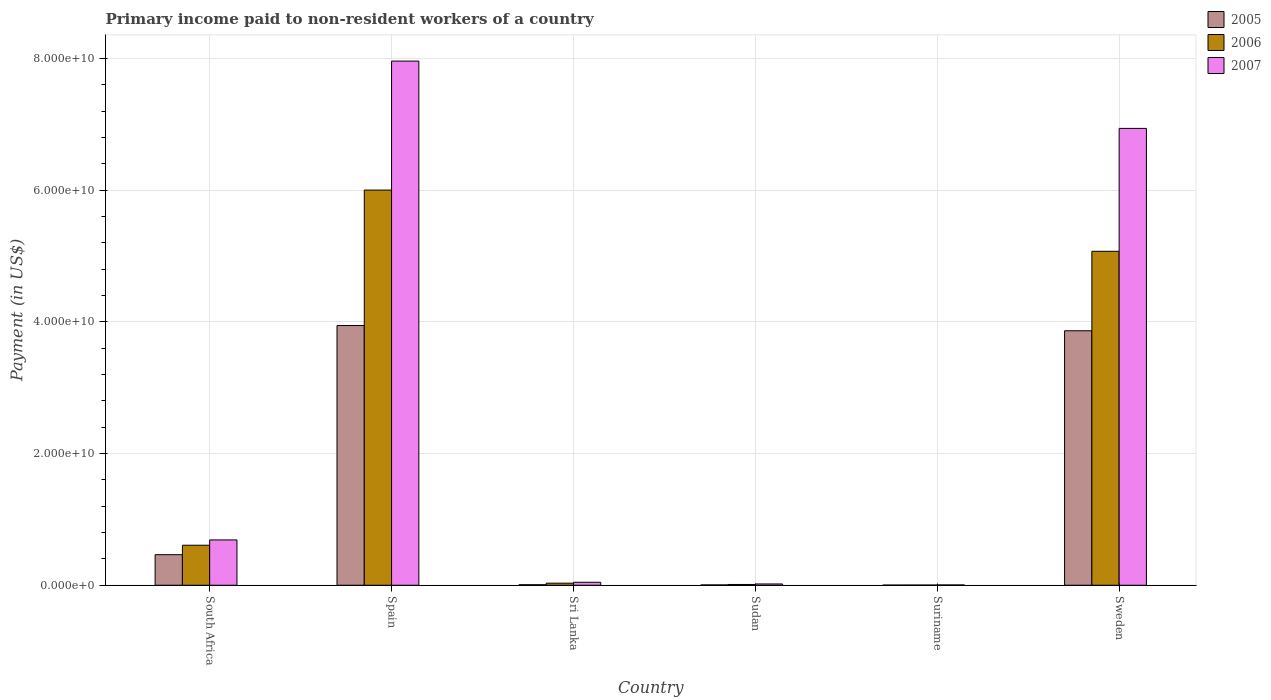How many bars are there on the 1st tick from the left?
Your answer should be very brief. 3. What is the amount paid to workers in 2007 in Suriname?
Offer a very short reply. 4.36e+07. Across all countries, what is the maximum amount paid to workers in 2005?
Provide a succinct answer. 3.94e+1. Across all countries, what is the minimum amount paid to workers in 2007?
Offer a terse response. 4.36e+07. In which country was the amount paid to workers in 2006 minimum?
Ensure brevity in your answer.  Suriname. What is the total amount paid to workers in 2007 in the graph?
Provide a succinct answer. 1.57e+11. What is the difference between the amount paid to workers in 2007 in South Africa and that in Spain?
Ensure brevity in your answer.  -7.27e+1. What is the difference between the amount paid to workers in 2006 in Sweden and the amount paid to workers in 2007 in Spain?
Give a very brief answer. -2.89e+1. What is the average amount paid to workers in 2006 per country?
Offer a terse response. 1.95e+1. What is the difference between the amount paid to workers of/in 2007 and amount paid to workers of/in 2005 in Suriname?
Keep it short and to the point. 1.96e+07. In how many countries, is the amount paid to workers in 2006 greater than 36000000000 US$?
Offer a very short reply. 2. What is the ratio of the amount paid to workers in 2005 in Spain to that in Sweden?
Provide a short and direct response. 1.02. What is the difference between the highest and the second highest amount paid to workers in 2006?
Keep it short and to the point. 9.30e+09. What is the difference between the highest and the lowest amount paid to workers in 2006?
Ensure brevity in your answer.  6.00e+1. In how many countries, is the amount paid to workers in 2005 greater than the average amount paid to workers in 2005 taken over all countries?
Provide a succinct answer. 2. Is the sum of the amount paid to workers in 2007 in Sri Lanka and Sudan greater than the maximum amount paid to workers in 2006 across all countries?
Your answer should be very brief. No. What does the 1st bar from the left in Sudan represents?
Keep it short and to the point. 2005. What does the 1st bar from the right in Suriname represents?
Give a very brief answer. 2007. Is it the case that in every country, the sum of the amount paid to workers in 2007 and amount paid to workers in 2005 is greater than the amount paid to workers in 2006?
Make the answer very short. Yes. How many bars are there?
Give a very brief answer. 18. Are all the bars in the graph horizontal?
Offer a terse response. No. How many countries are there in the graph?
Keep it short and to the point. 6. Are the values on the major ticks of Y-axis written in scientific E-notation?
Give a very brief answer. Yes. Does the graph contain grids?
Provide a short and direct response. Yes. Where does the legend appear in the graph?
Provide a short and direct response. Top right. How are the legend labels stacked?
Your response must be concise. Vertical. What is the title of the graph?
Keep it short and to the point. Primary income paid to non-resident workers of a country. What is the label or title of the Y-axis?
Your response must be concise. Payment (in US$). What is the Payment (in US$) of 2005 in South Africa?
Offer a very short reply. 4.64e+09. What is the Payment (in US$) of 2006 in South Africa?
Provide a succinct answer. 6.08e+09. What is the Payment (in US$) in 2007 in South Africa?
Your response must be concise. 6.88e+09. What is the Payment (in US$) in 2005 in Spain?
Ensure brevity in your answer.  3.94e+1. What is the Payment (in US$) of 2006 in Spain?
Your response must be concise. 6.00e+1. What is the Payment (in US$) in 2007 in Spain?
Your response must be concise. 7.96e+1. What is the Payment (in US$) in 2005 in Sri Lanka?
Your response must be concise. 7.59e+07. What is the Payment (in US$) in 2006 in Sri Lanka?
Provide a short and direct response. 3.12e+08. What is the Payment (in US$) of 2007 in Sri Lanka?
Give a very brief answer. 4.49e+08. What is the Payment (in US$) in 2005 in Sudan?
Provide a short and direct response. 4.79e+07. What is the Payment (in US$) in 2006 in Sudan?
Provide a succinct answer. 1.14e+08. What is the Payment (in US$) in 2007 in Sudan?
Offer a very short reply. 1.93e+08. What is the Payment (in US$) of 2005 in Suriname?
Give a very brief answer. 2.40e+07. What is the Payment (in US$) in 2006 in Suriname?
Keep it short and to the point. 2.50e+07. What is the Payment (in US$) of 2007 in Suriname?
Keep it short and to the point. 4.36e+07. What is the Payment (in US$) of 2005 in Sweden?
Give a very brief answer. 3.87e+1. What is the Payment (in US$) in 2006 in Sweden?
Keep it short and to the point. 5.07e+1. What is the Payment (in US$) in 2007 in Sweden?
Give a very brief answer. 6.94e+1. Across all countries, what is the maximum Payment (in US$) in 2005?
Provide a short and direct response. 3.94e+1. Across all countries, what is the maximum Payment (in US$) in 2006?
Your answer should be compact. 6.00e+1. Across all countries, what is the maximum Payment (in US$) of 2007?
Ensure brevity in your answer.  7.96e+1. Across all countries, what is the minimum Payment (in US$) of 2005?
Your response must be concise. 2.40e+07. Across all countries, what is the minimum Payment (in US$) of 2006?
Offer a very short reply. 2.50e+07. Across all countries, what is the minimum Payment (in US$) of 2007?
Provide a succinct answer. 4.36e+07. What is the total Payment (in US$) in 2005 in the graph?
Keep it short and to the point. 8.29e+1. What is the total Payment (in US$) of 2006 in the graph?
Give a very brief answer. 1.17e+11. What is the total Payment (in US$) in 2007 in the graph?
Give a very brief answer. 1.57e+11. What is the difference between the Payment (in US$) of 2005 in South Africa and that in Spain?
Offer a terse response. -3.48e+1. What is the difference between the Payment (in US$) in 2006 in South Africa and that in Spain?
Offer a terse response. -5.39e+1. What is the difference between the Payment (in US$) of 2007 in South Africa and that in Spain?
Provide a short and direct response. -7.27e+1. What is the difference between the Payment (in US$) of 2005 in South Africa and that in Sri Lanka?
Your response must be concise. 4.56e+09. What is the difference between the Payment (in US$) in 2006 in South Africa and that in Sri Lanka?
Provide a short and direct response. 5.77e+09. What is the difference between the Payment (in US$) of 2007 in South Africa and that in Sri Lanka?
Ensure brevity in your answer.  6.43e+09. What is the difference between the Payment (in US$) in 2005 in South Africa and that in Sudan?
Offer a very short reply. 4.59e+09. What is the difference between the Payment (in US$) of 2006 in South Africa and that in Sudan?
Offer a very short reply. 5.96e+09. What is the difference between the Payment (in US$) of 2007 in South Africa and that in Sudan?
Your answer should be compact. 6.69e+09. What is the difference between the Payment (in US$) in 2005 in South Africa and that in Suriname?
Your response must be concise. 4.62e+09. What is the difference between the Payment (in US$) of 2006 in South Africa and that in Suriname?
Keep it short and to the point. 6.05e+09. What is the difference between the Payment (in US$) of 2007 in South Africa and that in Suriname?
Your answer should be very brief. 6.84e+09. What is the difference between the Payment (in US$) in 2005 in South Africa and that in Sweden?
Provide a short and direct response. -3.40e+1. What is the difference between the Payment (in US$) in 2006 in South Africa and that in Sweden?
Ensure brevity in your answer.  -4.46e+1. What is the difference between the Payment (in US$) in 2007 in South Africa and that in Sweden?
Keep it short and to the point. -6.25e+1. What is the difference between the Payment (in US$) of 2005 in Spain and that in Sri Lanka?
Offer a very short reply. 3.94e+1. What is the difference between the Payment (in US$) in 2006 in Spain and that in Sri Lanka?
Make the answer very short. 5.97e+1. What is the difference between the Payment (in US$) in 2007 in Spain and that in Sri Lanka?
Provide a short and direct response. 7.92e+1. What is the difference between the Payment (in US$) of 2005 in Spain and that in Sudan?
Offer a terse response. 3.94e+1. What is the difference between the Payment (in US$) in 2006 in Spain and that in Sudan?
Give a very brief answer. 5.99e+1. What is the difference between the Payment (in US$) of 2007 in Spain and that in Sudan?
Offer a very short reply. 7.94e+1. What is the difference between the Payment (in US$) of 2005 in Spain and that in Suriname?
Offer a terse response. 3.94e+1. What is the difference between the Payment (in US$) of 2006 in Spain and that in Suriname?
Offer a terse response. 6.00e+1. What is the difference between the Payment (in US$) in 2007 in Spain and that in Suriname?
Provide a short and direct response. 7.96e+1. What is the difference between the Payment (in US$) of 2005 in Spain and that in Sweden?
Give a very brief answer. 7.95e+08. What is the difference between the Payment (in US$) in 2006 in Spain and that in Sweden?
Offer a very short reply. 9.30e+09. What is the difference between the Payment (in US$) of 2007 in Spain and that in Sweden?
Give a very brief answer. 1.02e+1. What is the difference between the Payment (in US$) in 2005 in Sri Lanka and that in Sudan?
Keep it short and to the point. 2.79e+07. What is the difference between the Payment (in US$) in 2006 in Sri Lanka and that in Sudan?
Make the answer very short. 1.97e+08. What is the difference between the Payment (in US$) of 2007 in Sri Lanka and that in Sudan?
Offer a very short reply. 2.56e+08. What is the difference between the Payment (in US$) in 2005 in Sri Lanka and that in Suriname?
Your answer should be compact. 5.19e+07. What is the difference between the Payment (in US$) in 2006 in Sri Lanka and that in Suriname?
Provide a succinct answer. 2.87e+08. What is the difference between the Payment (in US$) in 2007 in Sri Lanka and that in Suriname?
Keep it short and to the point. 4.06e+08. What is the difference between the Payment (in US$) of 2005 in Sri Lanka and that in Sweden?
Offer a very short reply. -3.86e+1. What is the difference between the Payment (in US$) of 2006 in Sri Lanka and that in Sweden?
Give a very brief answer. -5.04e+1. What is the difference between the Payment (in US$) in 2007 in Sri Lanka and that in Sweden?
Offer a terse response. -6.89e+1. What is the difference between the Payment (in US$) of 2005 in Sudan and that in Suriname?
Ensure brevity in your answer.  2.39e+07. What is the difference between the Payment (in US$) of 2006 in Sudan and that in Suriname?
Keep it short and to the point. 8.94e+07. What is the difference between the Payment (in US$) of 2007 in Sudan and that in Suriname?
Your answer should be compact. 1.49e+08. What is the difference between the Payment (in US$) in 2005 in Sudan and that in Sweden?
Provide a succinct answer. -3.86e+1. What is the difference between the Payment (in US$) of 2006 in Sudan and that in Sweden?
Provide a succinct answer. -5.06e+1. What is the difference between the Payment (in US$) of 2007 in Sudan and that in Sweden?
Provide a short and direct response. -6.92e+1. What is the difference between the Payment (in US$) of 2005 in Suriname and that in Sweden?
Your answer should be very brief. -3.86e+1. What is the difference between the Payment (in US$) of 2006 in Suriname and that in Sweden?
Provide a succinct answer. -5.07e+1. What is the difference between the Payment (in US$) in 2007 in Suriname and that in Sweden?
Keep it short and to the point. -6.93e+1. What is the difference between the Payment (in US$) of 2005 in South Africa and the Payment (in US$) of 2006 in Spain?
Provide a succinct answer. -5.54e+1. What is the difference between the Payment (in US$) of 2005 in South Africa and the Payment (in US$) of 2007 in Spain?
Your answer should be very brief. -7.50e+1. What is the difference between the Payment (in US$) in 2006 in South Africa and the Payment (in US$) in 2007 in Spain?
Your answer should be very brief. -7.35e+1. What is the difference between the Payment (in US$) in 2005 in South Africa and the Payment (in US$) in 2006 in Sri Lanka?
Provide a short and direct response. 4.33e+09. What is the difference between the Payment (in US$) of 2005 in South Africa and the Payment (in US$) of 2007 in Sri Lanka?
Keep it short and to the point. 4.19e+09. What is the difference between the Payment (in US$) of 2006 in South Africa and the Payment (in US$) of 2007 in Sri Lanka?
Offer a very short reply. 5.63e+09. What is the difference between the Payment (in US$) in 2005 in South Africa and the Payment (in US$) in 2006 in Sudan?
Offer a terse response. 4.53e+09. What is the difference between the Payment (in US$) of 2005 in South Africa and the Payment (in US$) of 2007 in Sudan?
Make the answer very short. 4.45e+09. What is the difference between the Payment (in US$) of 2006 in South Africa and the Payment (in US$) of 2007 in Sudan?
Make the answer very short. 5.89e+09. What is the difference between the Payment (in US$) in 2005 in South Africa and the Payment (in US$) in 2006 in Suriname?
Keep it short and to the point. 4.62e+09. What is the difference between the Payment (in US$) of 2005 in South Africa and the Payment (in US$) of 2007 in Suriname?
Your response must be concise. 4.60e+09. What is the difference between the Payment (in US$) in 2006 in South Africa and the Payment (in US$) in 2007 in Suriname?
Provide a succinct answer. 6.03e+09. What is the difference between the Payment (in US$) of 2005 in South Africa and the Payment (in US$) of 2006 in Sweden?
Give a very brief answer. -4.61e+1. What is the difference between the Payment (in US$) in 2005 in South Africa and the Payment (in US$) in 2007 in Sweden?
Keep it short and to the point. -6.47e+1. What is the difference between the Payment (in US$) of 2006 in South Africa and the Payment (in US$) of 2007 in Sweden?
Offer a very short reply. -6.33e+1. What is the difference between the Payment (in US$) in 2005 in Spain and the Payment (in US$) in 2006 in Sri Lanka?
Offer a very short reply. 3.91e+1. What is the difference between the Payment (in US$) of 2005 in Spain and the Payment (in US$) of 2007 in Sri Lanka?
Your response must be concise. 3.90e+1. What is the difference between the Payment (in US$) in 2006 in Spain and the Payment (in US$) in 2007 in Sri Lanka?
Offer a very short reply. 5.96e+1. What is the difference between the Payment (in US$) in 2005 in Spain and the Payment (in US$) in 2006 in Sudan?
Provide a succinct answer. 3.93e+1. What is the difference between the Payment (in US$) in 2005 in Spain and the Payment (in US$) in 2007 in Sudan?
Provide a short and direct response. 3.93e+1. What is the difference between the Payment (in US$) of 2006 in Spain and the Payment (in US$) of 2007 in Sudan?
Provide a succinct answer. 5.98e+1. What is the difference between the Payment (in US$) in 2005 in Spain and the Payment (in US$) in 2006 in Suriname?
Your response must be concise. 3.94e+1. What is the difference between the Payment (in US$) in 2005 in Spain and the Payment (in US$) in 2007 in Suriname?
Give a very brief answer. 3.94e+1. What is the difference between the Payment (in US$) of 2006 in Spain and the Payment (in US$) of 2007 in Suriname?
Make the answer very short. 6.00e+1. What is the difference between the Payment (in US$) in 2005 in Spain and the Payment (in US$) in 2006 in Sweden?
Your answer should be compact. -1.13e+1. What is the difference between the Payment (in US$) in 2005 in Spain and the Payment (in US$) in 2007 in Sweden?
Offer a very short reply. -2.99e+1. What is the difference between the Payment (in US$) in 2006 in Spain and the Payment (in US$) in 2007 in Sweden?
Provide a succinct answer. -9.37e+09. What is the difference between the Payment (in US$) of 2005 in Sri Lanka and the Payment (in US$) of 2006 in Sudan?
Your answer should be compact. -3.85e+07. What is the difference between the Payment (in US$) in 2005 in Sri Lanka and the Payment (in US$) in 2007 in Sudan?
Your answer should be compact. -1.17e+08. What is the difference between the Payment (in US$) in 2006 in Sri Lanka and the Payment (in US$) in 2007 in Sudan?
Keep it short and to the point. 1.19e+08. What is the difference between the Payment (in US$) of 2005 in Sri Lanka and the Payment (in US$) of 2006 in Suriname?
Provide a succinct answer. 5.09e+07. What is the difference between the Payment (in US$) in 2005 in Sri Lanka and the Payment (in US$) in 2007 in Suriname?
Keep it short and to the point. 3.23e+07. What is the difference between the Payment (in US$) in 2006 in Sri Lanka and the Payment (in US$) in 2007 in Suriname?
Provide a succinct answer. 2.68e+08. What is the difference between the Payment (in US$) of 2005 in Sri Lanka and the Payment (in US$) of 2006 in Sweden?
Ensure brevity in your answer.  -5.06e+1. What is the difference between the Payment (in US$) in 2005 in Sri Lanka and the Payment (in US$) in 2007 in Sweden?
Give a very brief answer. -6.93e+1. What is the difference between the Payment (in US$) in 2006 in Sri Lanka and the Payment (in US$) in 2007 in Sweden?
Your answer should be very brief. -6.91e+1. What is the difference between the Payment (in US$) in 2005 in Sudan and the Payment (in US$) in 2006 in Suriname?
Your answer should be compact. 2.29e+07. What is the difference between the Payment (in US$) in 2005 in Sudan and the Payment (in US$) in 2007 in Suriname?
Offer a terse response. 4.33e+06. What is the difference between the Payment (in US$) in 2006 in Sudan and the Payment (in US$) in 2007 in Suriname?
Keep it short and to the point. 7.08e+07. What is the difference between the Payment (in US$) in 2005 in Sudan and the Payment (in US$) in 2006 in Sweden?
Your response must be concise. -5.07e+1. What is the difference between the Payment (in US$) of 2005 in Sudan and the Payment (in US$) of 2007 in Sweden?
Provide a short and direct response. -6.93e+1. What is the difference between the Payment (in US$) of 2006 in Sudan and the Payment (in US$) of 2007 in Sweden?
Your answer should be compact. -6.93e+1. What is the difference between the Payment (in US$) of 2005 in Suriname and the Payment (in US$) of 2006 in Sweden?
Offer a very short reply. -5.07e+1. What is the difference between the Payment (in US$) of 2005 in Suriname and the Payment (in US$) of 2007 in Sweden?
Offer a terse response. -6.94e+1. What is the difference between the Payment (in US$) of 2006 in Suriname and the Payment (in US$) of 2007 in Sweden?
Ensure brevity in your answer.  -6.94e+1. What is the average Payment (in US$) of 2005 per country?
Your response must be concise. 1.38e+1. What is the average Payment (in US$) of 2006 per country?
Make the answer very short. 1.95e+1. What is the average Payment (in US$) in 2007 per country?
Offer a terse response. 2.61e+1. What is the difference between the Payment (in US$) in 2005 and Payment (in US$) in 2006 in South Africa?
Provide a short and direct response. -1.44e+09. What is the difference between the Payment (in US$) in 2005 and Payment (in US$) in 2007 in South Africa?
Keep it short and to the point. -2.24e+09. What is the difference between the Payment (in US$) in 2006 and Payment (in US$) in 2007 in South Africa?
Offer a very short reply. -8.03e+08. What is the difference between the Payment (in US$) of 2005 and Payment (in US$) of 2006 in Spain?
Ensure brevity in your answer.  -2.06e+1. What is the difference between the Payment (in US$) in 2005 and Payment (in US$) in 2007 in Spain?
Offer a very short reply. -4.02e+1. What is the difference between the Payment (in US$) of 2006 and Payment (in US$) of 2007 in Spain?
Your response must be concise. -1.96e+1. What is the difference between the Payment (in US$) in 2005 and Payment (in US$) in 2006 in Sri Lanka?
Your response must be concise. -2.36e+08. What is the difference between the Payment (in US$) in 2005 and Payment (in US$) in 2007 in Sri Lanka?
Keep it short and to the point. -3.73e+08. What is the difference between the Payment (in US$) in 2006 and Payment (in US$) in 2007 in Sri Lanka?
Make the answer very short. -1.38e+08. What is the difference between the Payment (in US$) in 2005 and Payment (in US$) in 2006 in Sudan?
Ensure brevity in your answer.  -6.65e+07. What is the difference between the Payment (in US$) of 2005 and Payment (in US$) of 2007 in Sudan?
Your answer should be compact. -1.45e+08. What is the difference between the Payment (in US$) of 2006 and Payment (in US$) of 2007 in Sudan?
Keep it short and to the point. -7.85e+07. What is the difference between the Payment (in US$) in 2005 and Payment (in US$) in 2006 in Suriname?
Make the answer very short. -1.00e+06. What is the difference between the Payment (in US$) of 2005 and Payment (in US$) of 2007 in Suriname?
Ensure brevity in your answer.  -1.96e+07. What is the difference between the Payment (in US$) of 2006 and Payment (in US$) of 2007 in Suriname?
Offer a very short reply. -1.86e+07. What is the difference between the Payment (in US$) in 2005 and Payment (in US$) in 2006 in Sweden?
Keep it short and to the point. -1.21e+1. What is the difference between the Payment (in US$) in 2005 and Payment (in US$) in 2007 in Sweden?
Give a very brief answer. -3.07e+1. What is the difference between the Payment (in US$) in 2006 and Payment (in US$) in 2007 in Sweden?
Make the answer very short. -1.87e+1. What is the ratio of the Payment (in US$) of 2005 in South Africa to that in Spain?
Provide a succinct answer. 0.12. What is the ratio of the Payment (in US$) of 2006 in South Africa to that in Spain?
Provide a short and direct response. 0.1. What is the ratio of the Payment (in US$) in 2007 in South Africa to that in Spain?
Provide a short and direct response. 0.09. What is the ratio of the Payment (in US$) of 2005 in South Africa to that in Sri Lanka?
Provide a short and direct response. 61.16. What is the ratio of the Payment (in US$) of 2006 in South Africa to that in Sri Lanka?
Give a very brief answer. 19.51. What is the ratio of the Payment (in US$) in 2007 in South Africa to that in Sri Lanka?
Keep it short and to the point. 15.32. What is the ratio of the Payment (in US$) of 2005 in South Africa to that in Sudan?
Your response must be concise. 96.81. What is the ratio of the Payment (in US$) of 2006 in South Africa to that in Sudan?
Keep it short and to the point. 53.14. What is the ratio of the Payment (in US$) in 2007 in South Africa to that in Sudan?
Make the answer very short. 35.68. What is the ratio of the Payment (in US$) in 2005 in South Africa to that in Suriname?
Provide a short and direct response. 193.35. What is the ratio of the Payment (in US$) of 2006 in South Africa to that in Suriname?
Keep it short and to the point. 243.13. What is the ratio of the Payment (in US$) in 2007 in South Africa to that in Suriname?
Make the answer very short. 157.83. What is the ratio of the Payment (in US$) of 2005 in South Africa to that in Sweden?
Your answer should be very brief. 0.12. What is the ratio of the Payment (in US$) in 2006 in South Africa to that in Sweden?
Provide a succinct answer. 0.12. What is the ratio of the Payment (in US$) of 2007 in South Africa to that in Sweden?
Keep it short and to the point. 0.1. What is the ratio of the Payment (in US$) in 2005 in Spain to that in Sri Lanka?
Offer a very short reply. 519.93. What is the ratio of the Payment (in US$) in 2006 in Spain to that in Sri Lanka?
Provide a short and direct response. 192.63. What is the ratio of the Payment (in US$) of 2007 in Spain to that in Sri Lanka?
Ensure brevity in your answer.  177.26. What is the ratio of the Payment (in US$) of 2005 in Spain to that in Sudan?
Your answer should be compact. 822.93. What is the ratio of the Payment (in US$) in 2006 in Spain to that in Sudan?
Provide a short and direct response. 524.75. What is the ratio of the Payment (in US$) of 2007 in Spain to that in Sudan?
Provide a succinct answer. 412.79. What is the ratio of the Payment (in US$) of 2005 in Spain to that in Suriname?
Provide a succinct answer. 1643.54. What is the ratio of the Payment (in US$) in 2006 in Spain to that in Suriname?
Your response must be concise. 2400.9. What is the ratio of the Payment (in US$) in 2007 in Spain to that in Suriname?
Ensure brevity in your answer.  1826.02. What is the ratio of the Payment (in US$) of 2005 in Spain to that in Sweden?
Offer a very short reply. 1.02. What is the ratio of the Payment (in US$) of 2006 in Spain to that in Sweden?
Your answer should be compact. 1.18. What is the ratio of the Payment (in US$) in 2007 in Spain to that in Sweden?
Ensure brevity in your answer.  1.15. What is the ratio of the Payment (in US$) of 2005 in Sri Lanka to that in Sudan?
Your answer should be compact. 1.58. What is the ratio of the Payment (in US$) in 2006 in Sri Lanka to that in Sudan?
Make the answer very short. 2.72. What is the ratio of the Payment (in US$) of 2007 in Sri Lanka to that in Sudan?
Keep it short and to the point. 2.33. What is the ratio of the Payment (in US$) of 2005 in Sri Lanka to that in Suriname?
Your response must be concise. 3.16. What is the ratio of the Payment (in US$) in 2006 in Sri Lanka to that in Suriname?
Your answer should be compact. 12.46. What is the ratio of the Payment (in US$) in 2007 in Sri Lanka to that in Suriname?
Your response must be concise. 10.3. What is the ratio of the Payment (in US$) of 2005 in Sri Lanka to that in Sweden?
Provide a succinct answer. 0. What is the ratio of the Payment (in US$) in 2006 in Sri Lanka to that in Sweden?
Your response must be concise. 0.01. What is the ratio of the Payment (in US$) of 2007 in Sri Lanka to that in Sweden?
Offer a very short reply. 0.01. What is the ratio of the Payment (in US$) in 2005 in Sudan to that in Suriname?
Your answer should be very brief. 2. What is the ratio of the Payment (in US$) of 2006 in Sudan to that in Suriname?
Make the answer very short. 4.58. What is the ratio of the Payment (in US$) in 2007 in Sudan to that in Suriname?
Ensure brevity in your answer.  4.42. What is the ratio of the Payment (in US$) of 2005 in Sudan to that in Sweden?
Your response must be concise. 0. What is the ratio of the Payment (in US$) of 2006 in Sudan to that in Sweden?
Offer a very short reply. 0. What is the ratio of the Payment (in US$) in 2007 in Sudan to that in Sweden?
Your answer should be compact. 0. What is the ratio of the Payment (in US$) of 2005 in Suriname to that in Sweden?
Make the answer very short. 0. What is the ratio of the Payment (in US$) of 2006 in Suriname to that in Sweden?
Provide a succinct answer. 0. What is the ratio of the Payment (in US$) of 2007 in Suriname to that in Sweden?
Offer a terse response. 0. What is the difference between the highest and the second highest Payment (in US$) of 2005?
Your answer should be compact. 7.95e+08. What is the difference between the highest and the second highest Payment (in US$) in 2006?
Make the answer very short. 9.30e+09. What is the difference between the highest and the second highest Payment (in US$) of 2007?
Offer a terse response. 1.02e+1. What is the difference between the highest and the lowest Payment (in US$) in 2005?
Provide a short and direct response. 3.94e+1. What is the difference between the highest and the lowest Payment (in US$) in 2006?
Offer a very short reply. 6.00e+1. What is the difference between the highest and the lowest Payment (in US$) of 2007?
Offer a terse response. 7.96e+1. 